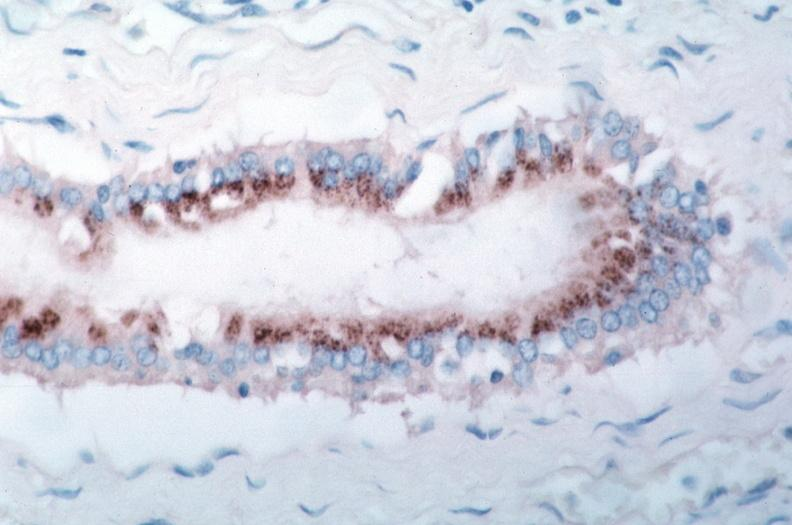s mesothelioma present?
Answer the question using a single word or phrase. No 